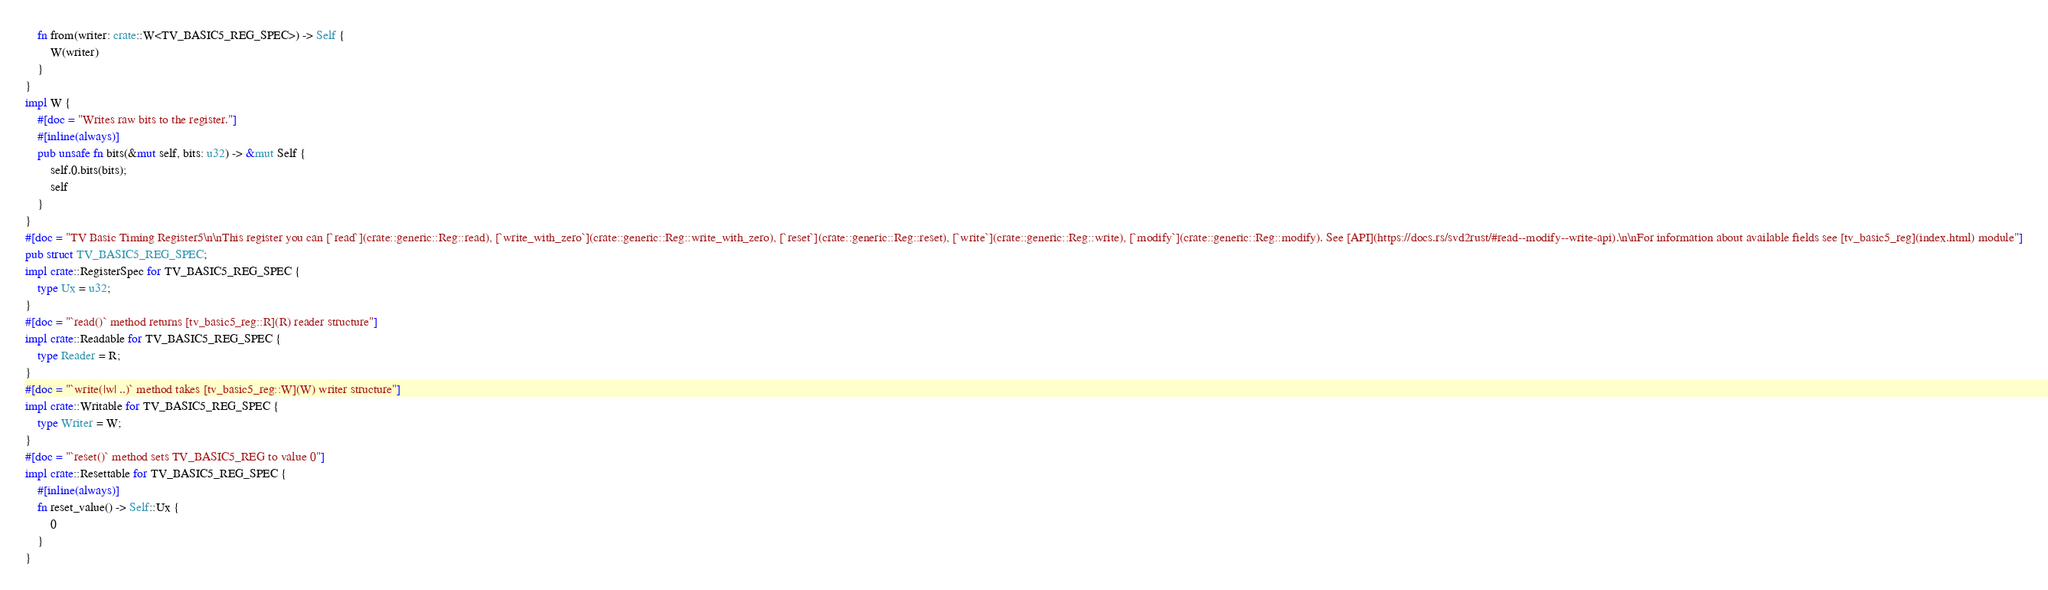<code> <loc_0><loc_0><loc_500><loc_500><_Rust_>    fn from(writer: crate::W<TV_BASIC5_REG_SPEC>) -> Self {
        W(writer)
    }
}
impl W {
    #[doc = "Writes raw bits to the register."]
    #[inline(always)]
    pub unsafe fn bits(&mut self, bits: u32) -> &mut Self {
        self.0.bits(bits);
        self
    }
}
#[doc = "TV Basic Timing Register5\n\nThis register you can [`read`](crate::generic::Reg::read), [`write_with_zero`](crate::generic::Reg::write_with_zero), [`reset`](crate::generic::Reg::reset), [`write`](crate::generic::Reg::write), [`modify`](crate::generic::Reg::modify). See [API](https://docs.rs/svd2rust/#read--modify--write-api).\n\nFor information about available fields see [tv_basic5_reg](index.html) module"]
pub struct TV_BASIC5_REG_SPEC;
impl crate::RegisterSpec for TV_BASIC5_REG_SPEC {
    type Ux = u32;
}
#[doc = "`read()` method returns [tv_basic5_reg::R](R) reader structure"]
impl crate::Readable for TV_BASIC5_REG_SPEC {
    type Reader = R;
}
#[doc = "`write(|w| ..)` method takes [tv_basic5_reg::W](W) writer structure"]
impl crate::Writable for TV_BASIC5_REG_SPEC {
    type Writer = W;
}
#[doc = "`reset()` method sets TV_BASIC5_REG to value 0"]
impl crate::Resettable for TV_BASIC5_REG_SPEC {
    #[inline(always)]
    fn reset_value() -> Self::Ux {
        0
    }
}
</code> 